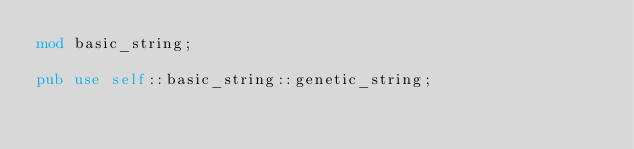Convert code to text. <code><loc_0><loc_0><loc_500><loc_500><_Rust_>mod basic_string;

pub use self::basic_string::genetic_string;
</code> 